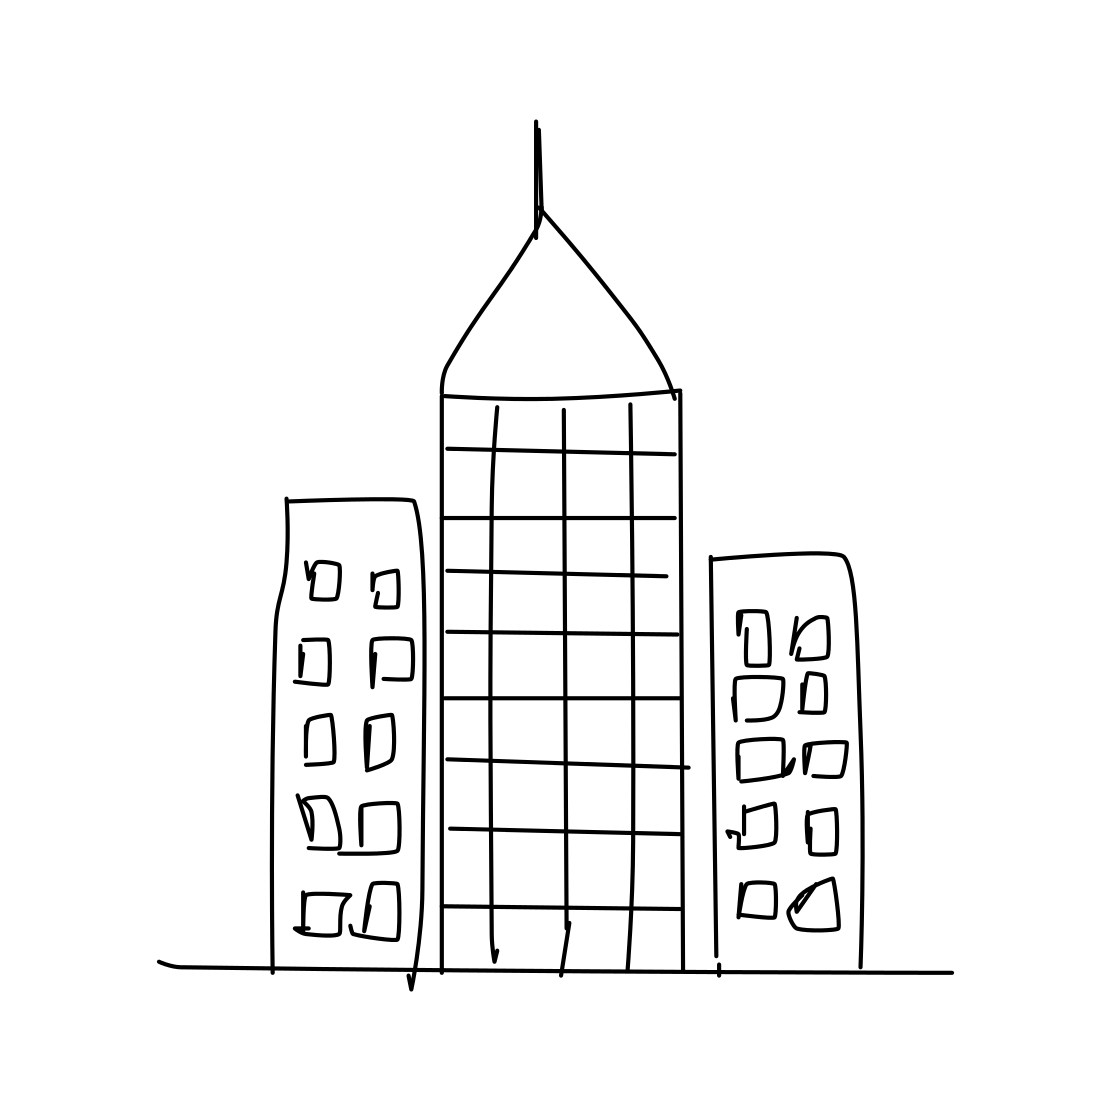In the scene, is an apple in it? No, there is no apple in the scene. The image depicts a simple line drawing of three buildings, predominantly featuring a skyscraper in the center with a pointed roof and grid-like windows, flanked by two smaller buildings with irregular window patterns. 